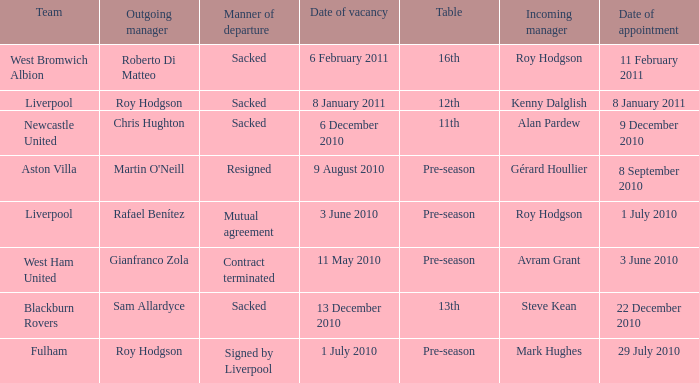Could you parse the entire table? {'header': ['Team', 'Outgoing manager', 'Manner of departure', 'Date of vacancy', 'Table', 'Incoming manager', 'Date of appointment'], 'rows': [['West Bromwich Albion', 'Roberto Di Matteo', 'Sacked', '6 February 2011', '16th', 'Roy Hodgson', '11 February 2011'], ['Liverpool', 'Roy Hodgson', 'Sacked', '8 January 2011', '12th', 'Kenny Dalglish', '8 January 2011'], ['Newcastle United', 'Chris Hughton', 'Sacked', '6 December 2010', '11th', 'Alan Pardew', '9 December 2010'], ['Aston Villa', "Martin O'Neill", 'Resigned', '9 August 2010', 'Pre-season', 'Gérard Houllier', '8 September 2010'], ['Liverpool', 'Rafael Benítez', 'Mutual agreement', '3 June 2010', 'Pre-season', 'Roy Hodgson', '1 July 2010'], ['West Ham United', 'Gianfranco Zola', 'Contract terminated', '11 May 2010', 'Pre-season', 'Avram Grant', '3 June 2010'], ['Blackburn Rovers', 'Sam Allardyce', 'Sacked', '13 December 2010', '13th', 'Steve Kean', '22 December 2010'], ['Fulham', 'Roy Hodgson', 'Signed by Liverpool', '1 July 2010', 'Pre-season', 'Mark Hughes', '29 July 2010']]} What is the table for the team Blackburn Rovers? 13th. 